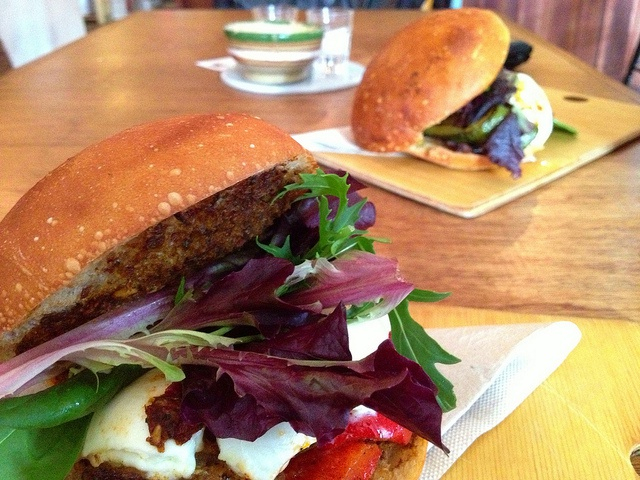Describe the objects in this image and their specific colors. I can see dining table in tan, maroon, black, ivory, and white tones, sandwich in white, black, maroon, darkgreen, and ivory tones, sandwich in white, salmon, red, and maroon tones, sandwich in white, orange, red, salmon, and khaki tones, and bowl in lightgray, ivory, darkgray, tan, and green tones in this image. 